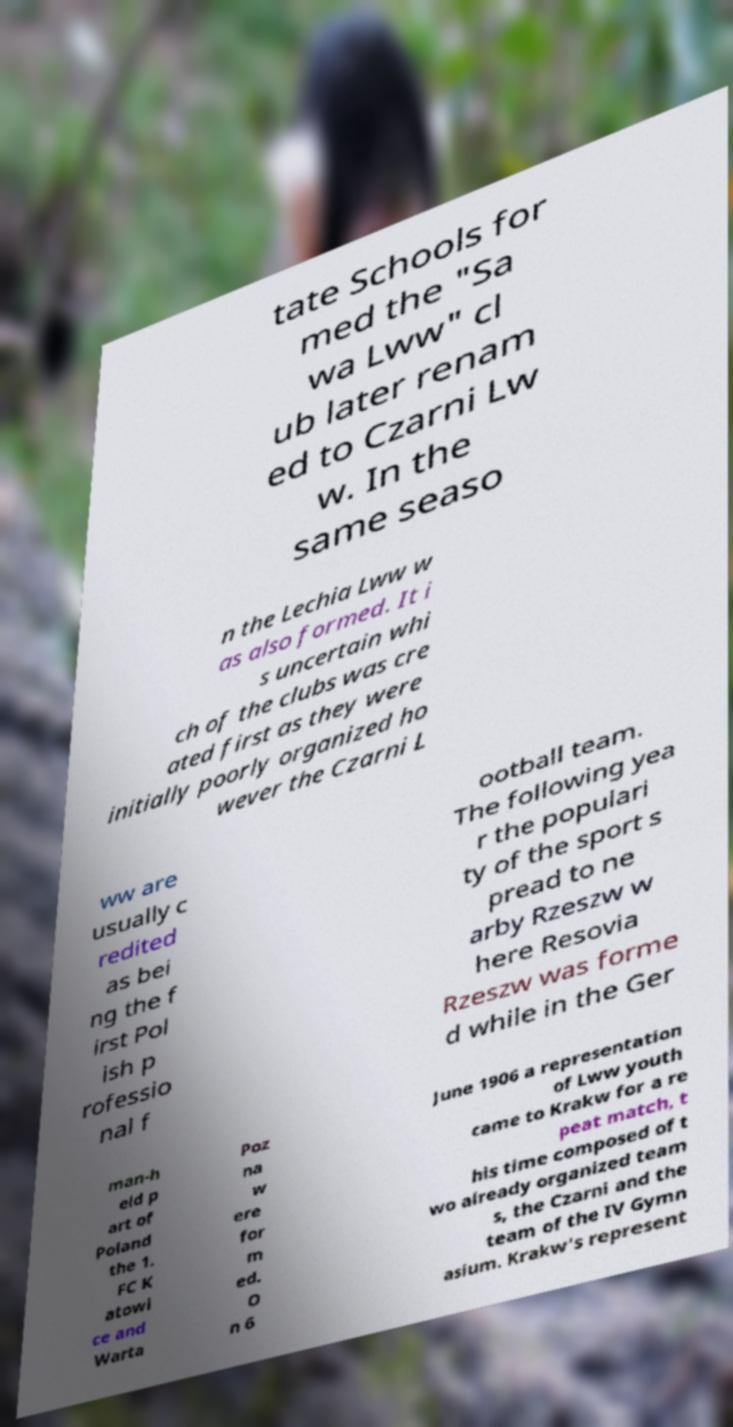Please read and relay the text visible in this image. What does it say? tate Schools for med the "Sa wa Lww" cl ub later renam ed to Czarni Lw w. In the same seaso n the Lechia Lww w as also formed. It i s uncertain whi ch of the clubs was cre ated first as they were initially poorly organized ho wever the Czarni L ww are usually c redited as bei ng the f irst Pol ish p rofessio nal f ootball team. The following yea r the populari ty of the sport s pread to ne arby Rzeszw w here Resovia Rzeszw was forme d while in the Ger man-h eld p art of Poland the 1. FC K atowi ce and Warta Poz na w ere for m ed. O n 6 June 1906 a representation of Lww youth came to Krakw for a re peat match, t his time composed of t wo already organized team s, the Czarni and the team of the IV Gymn asium. Krakw's represent 